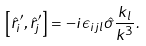<formula> <loc_0><loc_0><loc_500><loc_500>\left [ { \hat { r } ^ { \prime } _ { i } , \hat { r } ^ { \prime } _ { j } } \right ] = - i \epsilon _ { i j l } \hat { \sigma } \frac { k _ { l } } { k ^ { 3 } } .</formula> 